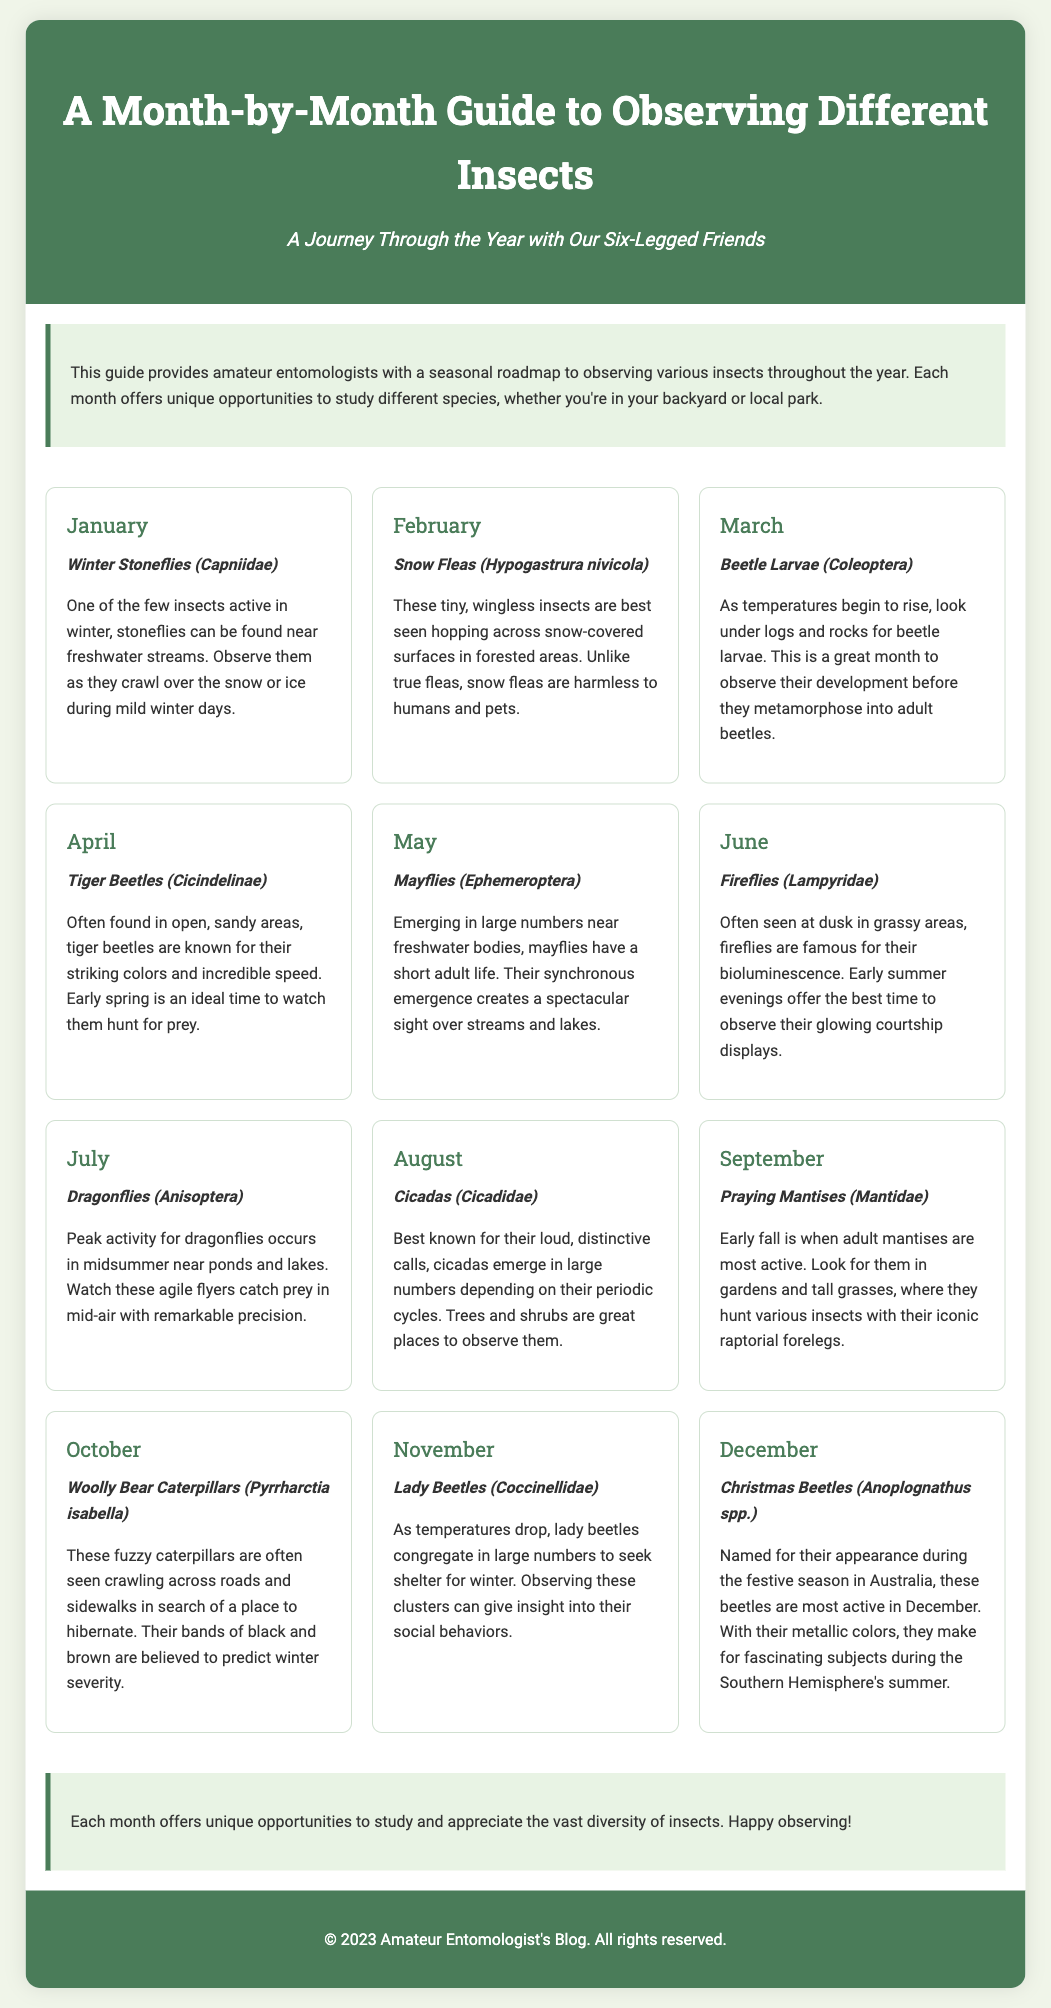What insect is observed in January? The document states that Winter Stoneflies (Capniidae) are observed in January.
Answer: Winter Stoneflies (Capniidae) What is the primary behavior of fireflies in June? According to the document, fireflies are known for their bioluminescence and display glowing courtship behaviors.
Answer: Glowing courtship displays Which month features the emergence of mayflies? The document indicates that mayflies emerge in large numbers in May.
Answer: May List one insect that is active in December. The document mentions Christmas Beetles (Anoplognathus spp.) as active in December.
Answer: Christmas Beetles (Anoplognathus spp.) What do snow fleas look like? The document describes snow fleas as tiny, wingless insects that hop across snow-covered surfaces.
Answer: Tiny, wingless insects In which month can you observe dragonflies primarily? The document states that July is the peak activity month for dragonflies.
Answer: July How do lady beetles behave in November? The document mentions that lady beetles congregate in large numbers to seek shelter for winter.
Answer: Congregate for shelter What is the main focus of this guide? The document's introduction explains that the guide provides a roadmap for observing various insects throughout the year.
Answer: Observing various insects What time of year is ideal to see tiger beetles? The document states that early spring is an ideal time to watch tiger beetles.
Answer: Early spring 